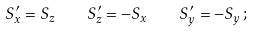<formula> <loc_0><loc_0><loc_500><loc_500>S _ { x } ^ { \prime } = S _ { z } \quad S _ { z } ^ { \prime } = - S _ { x } \quad S _ { y } ^ { \prime } = - S _ { y } \, ;</formula> 